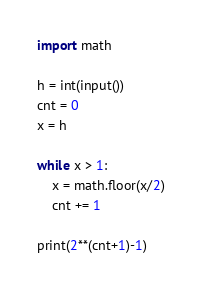<code> <loc_0><loc_0><loc_500><loc_500><_Python_>import math

h = int(input())
cnt = 0
x = h

while x > 1:
    x = math.floor(x/2)
    cnt += 1

print(2**(cnt+1)-1)
</code> 